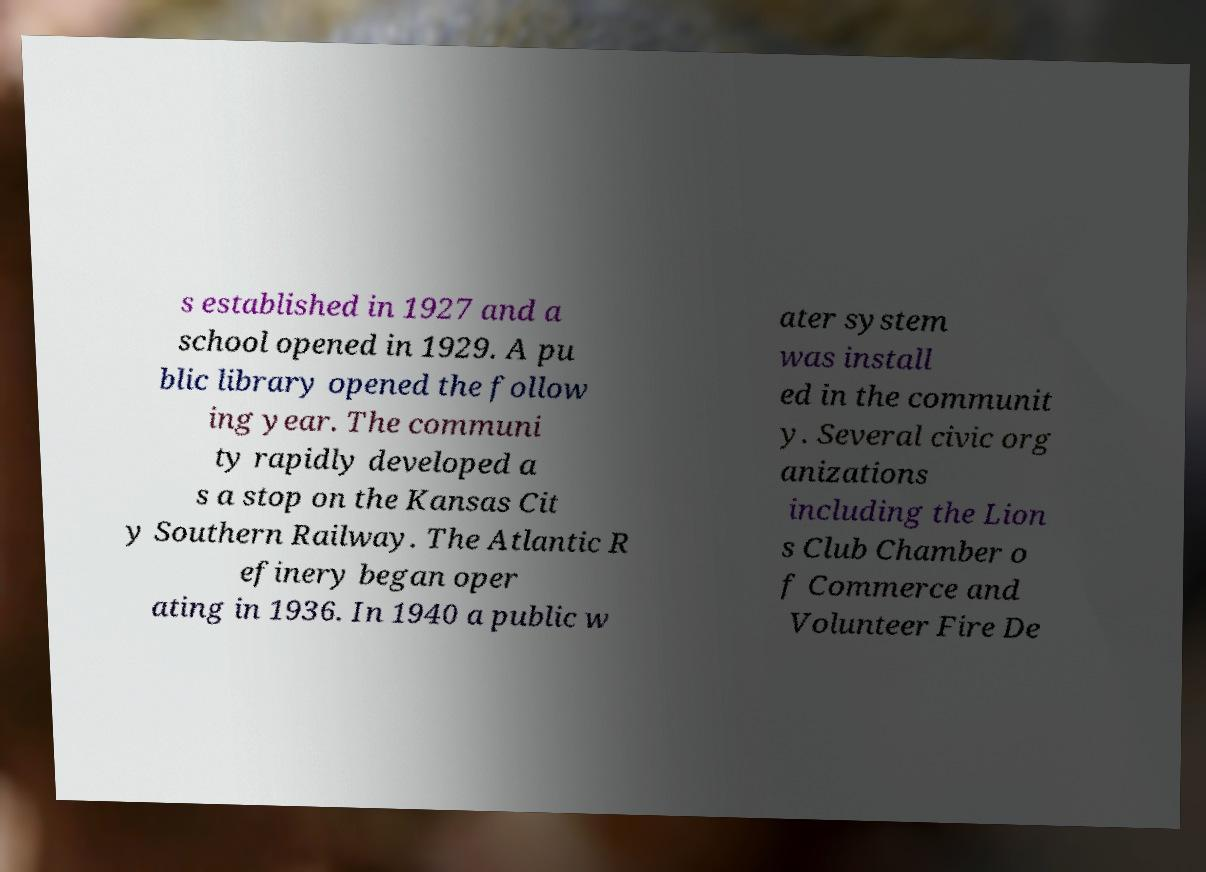Please read and relay the text visible in this image. What does it say? s established in 1927 and a school opened in 1929. A pu blic library opened the follow ing year. The communi ty rapidly developed a s a stop on the Kansas Cit y Southern Railway. The Atlantic R efinery began oper ating in 1936. In 1940 a public w ater system was install ed in the communit y. Several civic org anizations including the Lion s Club Chamber o f Commerce and Volunteer Fire De 